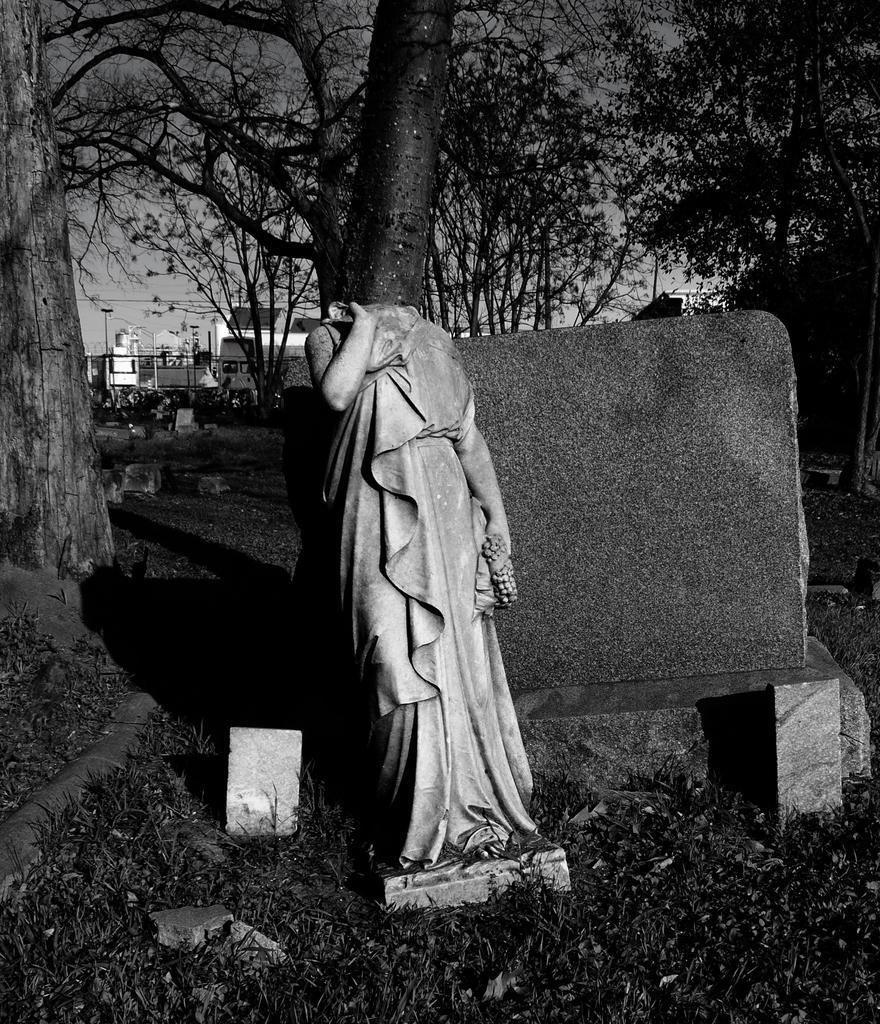Describe this image in one or two sentences. This is a black and white pic. Here we can see a statue of a person and the head of it is broken. In the background there are buildings,poles,trees and sky. 